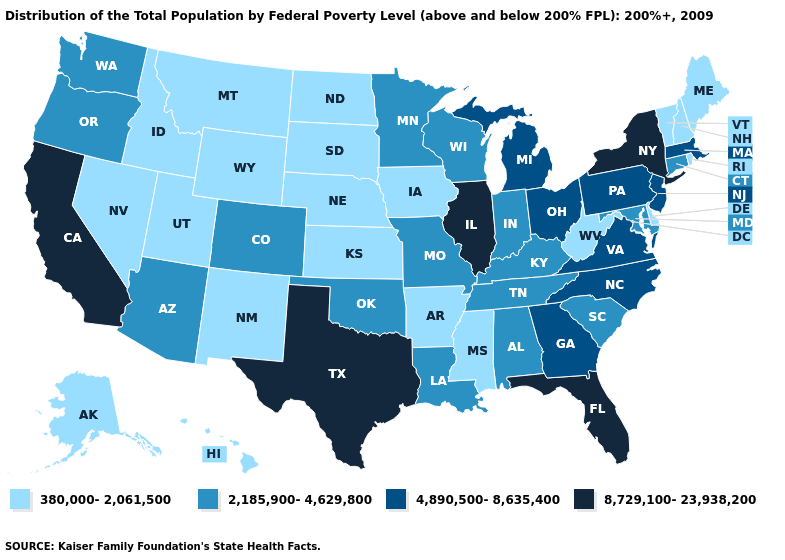Name the states that have a value in the range 4,890,500-8,635,400?
Answer briefly. Georgia, Massachusetts, Michigan, New Jersey, North Carolina, Ohio, Pennsylvania, Virginia. How many symbols are there in the legend?
Give a very brief answer. 4. What is the lowest value in states that border Wisconsin?
Write a very short answer. 380,000-2,061,500. What is the value of Idaho?
Be succinct. 380,000-2,061,500. How many symbols are there in the legend?
Write a very short answer. 4. What is the lowest value in states that border Arkansas?
Quick response, please. 380,000-2,061,500. What is the value of Vermont?
Give a very brief answer. 380,000-2,061,500. Name the states that have a value in the range 2,185,900-4,629,800?
Answer briefly. Alabama, Arizona, Colorado, Connecticut, Indiana, Kentucky, Louisiana, Maryland, Minnesota, Missouri, Oklahoma, Oregon, South Carolina, Tennessee, Washington, Wisconsin. Does the first symbol in the legend represent the smallest category?
Concise answer only. Yes. What is the lowest value in states that border Missouri?
Short answer required. 380,000-2,061,500. Does Illinois have the highest value in the USA?
Write a very short answer. Yes. Name the states that have a value in the range 8,729,100-23,938,200?
Write a very short answer. California, Florida, Illinois, New York, Texas. What is the value of Arizona?
Give a very brief answer. 2,185,900-4,629,800. What is the value of Indiana?
Be succinct. 2,185,900-4,629,800. What is the lowest value in the South?
Keep it brief. 380,000-2,061,500. 